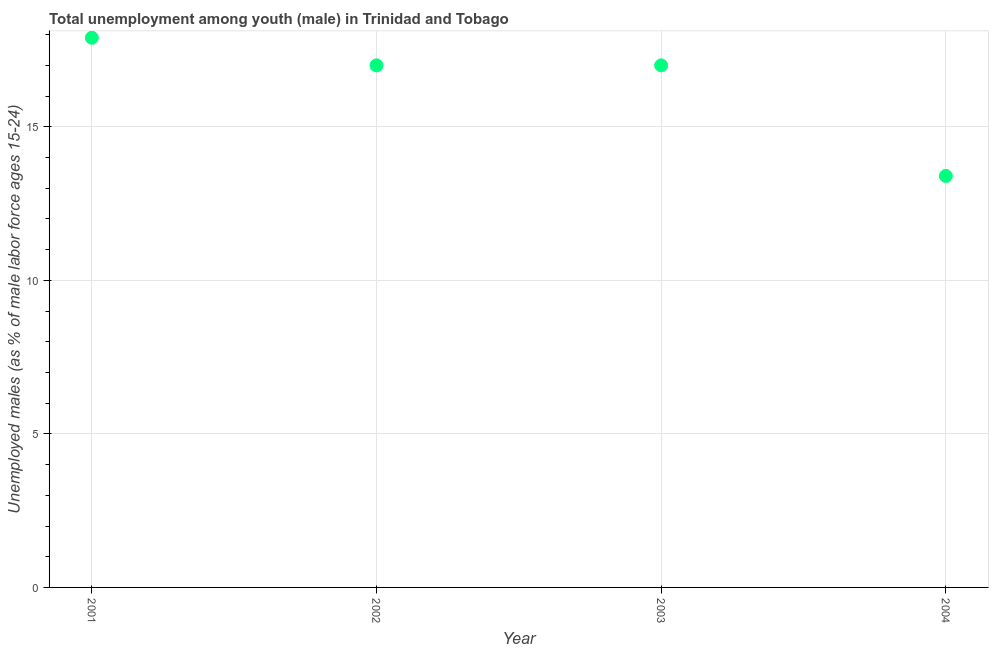What is the unemployed male youth population in 2002?
Offer a terse response. 17. Across all years, what is the maximum unemployed male youth population?
Your answer should be very brief. 17.9. Across all years, what is the minimum unemployed male youth population?
Your answer should be very brief. 13.4. In which year was the unemployed male youth population maximum?
Make the answer very short. 2001. What is the sum of the unemployed male youth population?
Provide a short and direct response. 65.3. What is the difference between the unemployed male youth population in 2001 and 2004?
Make the answer very short. 4.5. What is the average unemployed male youth population per year?
Provide a succinct answer. 16.32. What is the median unemployed male youth population?
Provide a succinct answer. 17. In how many years, is the unemployed male youth population greater than 5 %?
Your response must be concise. 4. Do a majority of the years between 2004 and 2003 (inclusive) have unemployed male youth population greater than 14 %?
Offer a very short reply. No. What is the ratio of the unemployed male youth population in 2001 to that in 2003?
Make the answer very short. 1.05. Is the difference between the unemployed male youth population in 2001 and 2003 greater than the difference between any two years?
Provide a short and direct response. No. What is the difference between the highest and the second highest unemployed male youth population?
Keep it short and to the point. 0.9. What is the difference between the highest and the lowest unemployed male youth population?
Your answer should be compact. 4.5. In how many years, is the unemployed male youth population greater than the average unemployed male youth population taken over all years?
Provide a short and direct response. 3. Does the unemployed male youth population monotonically increase over the years?
Your response must be concise. No. How many dotlines are there?
Make the answer very short. 1. How many years are there in the graph?
Offer a terse response. 4. What is the title of the graph?
Your response must be concise. Total unemployment among youth (male) in Trinidad and Tobago. What is the label or title of the Y-axis?
Your answer should be very brief. Unemployed males (as % of male labor force ages 15-24). What is the Unemployed males (as % of male labor force ages 15-24) in 2001?
Keep it short and to the point. 17.9. What is the Unemployed males (as % of male labor force ages 15-24) in 2002?
Offer a very short reply. 17. What is the Unemployed males (as % of male labor force ages 15-24) in 2004?
Ensure brevity in your answer.  13.4. What is the difference between the Unemployed males (as % of male labor force ages 15-24) in 2001 and 2004?
Your answer should be compact. 4.5. What is the ratio of the Unemployed males (as % of male labor force ages 15-24) in 2001 to that in 2002?
Keep it short and to the point. 1.05. What is the ratio of the Unemployed males (as % of male labor force ages 15-24) in 2001 to that in 2003?
Provide a short and direct response. 1.05. What is the ratio of the Unemployed males (as % of male labor force ages 15-24) in 2001 to that in 2004?
Provide a succinct answer. 1.34. What is the ratio of the Unemployed males (as % of male labor force ages 15-24) in 2002 to that in 2004?
Keep it short and to the point. 1.27. What is the ratio of the Unemployed males (as % of male labor force ages 15-24) in 2003 to that in 2004?
Make the answer very short. 1.27. 